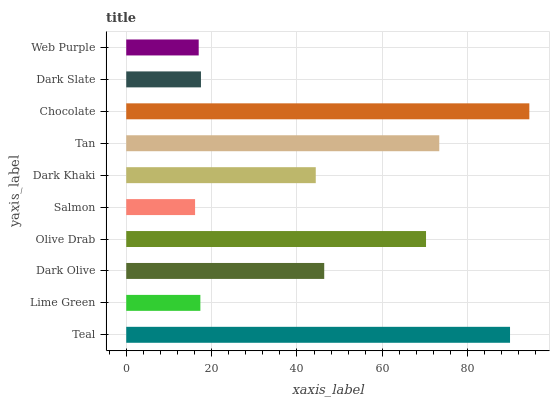Is Salmon the minimum?
Answer yes or no. Yes. Is Chocolate the maximum?
Answer yes or no. Yes. Is Lime Green the minimum?
Answer yes or no. No. Is Lime Green the maximum?
Answer yes or no. No. Is Teal greater than Lime Green?
Answer yes or no. Yes. Is Lime Green less than Teal?
Answer yes or no. Yes. Is Lime Green greater than Teal?
Answer yes or no. No. Is Teal less than Lime Green?
Answer yes or no. No. Is Dark Olive the high median?
Answer yes or no. Yes. Is Dark Khaki the low median?
Answer yes or no. Yes. Is Dark Khaki the high median?
Answer yes or no. No. Is Teal the low median?
Answer yes or no. No. 